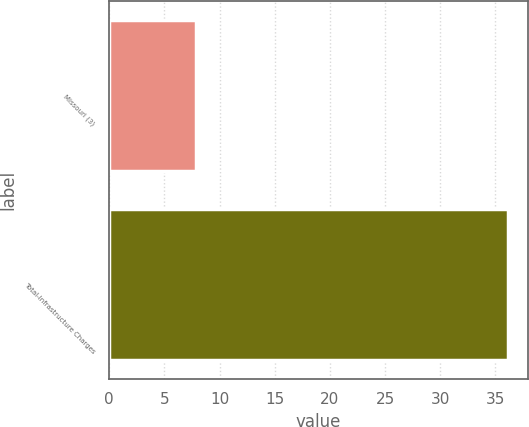<chart> <loc_0><loc_0><loc_500><loc_500><bar_chart><fcel>Missouri (3)<fcel>Total-Infrastructure Charges<nl><fcel>7.9<fcel>36.1<nl></chart> 